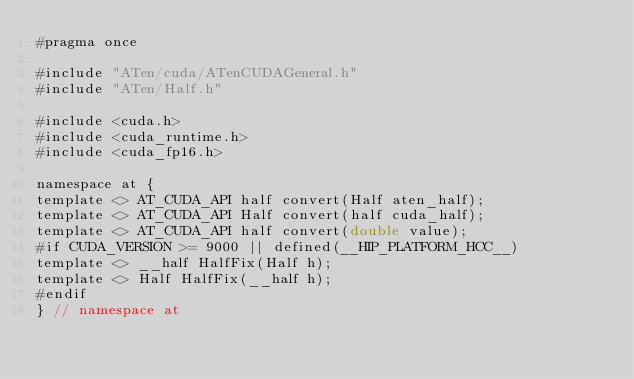Convert code to text. <code><loc_0><loc_0><loc_500><loc_500><_Cuda_>#pragma once

#include "ATen/cuda/ATenCUDAGeneral.h"
#include "ATen/Half.h"

#include <cuda.h>
#include <cuda_runtime.h>
#include <cuda_fp16.h>

namespace at {
template <> AT_CUDA_API half convert(Half aten_half);
template <> AT_CUDA_API Half convert(half cuda_half);
template <> AT_CUDA_API half convert(double value);
#if CUDA_VERSION >= 9000 || defined(__HIP_PLATFORM_HCC__)
template <> __half HalfFix(Half h);
template <> Half HalfFix(__half h);
#endif
} // namespace at
</code> 